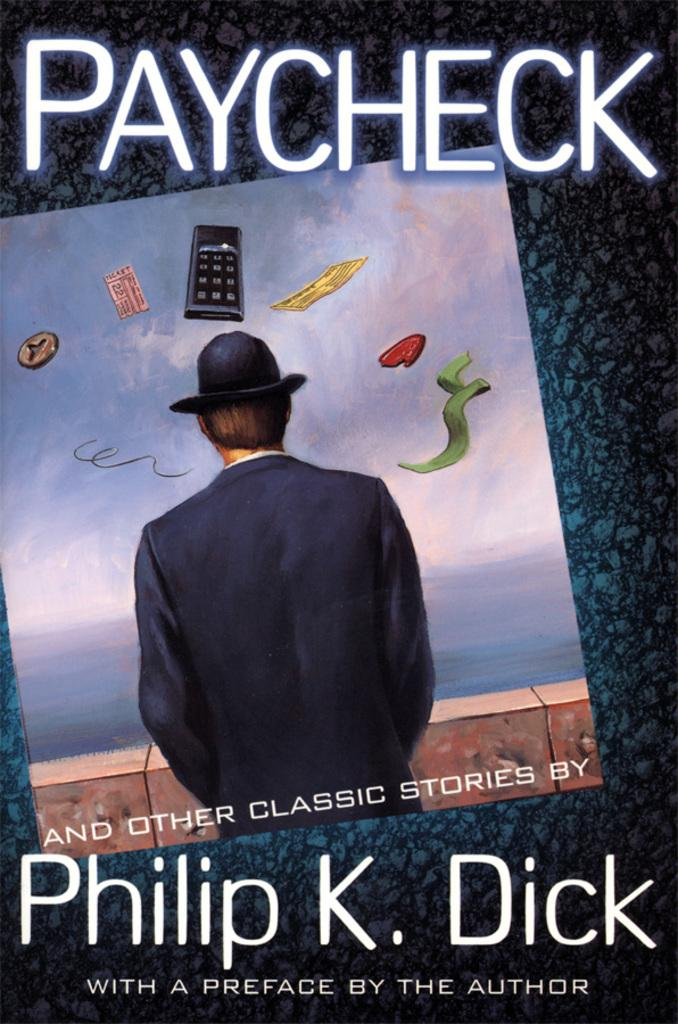Provide a one-sentence caption for the provided image. Book called paycheck from Philip K Dick the author. 